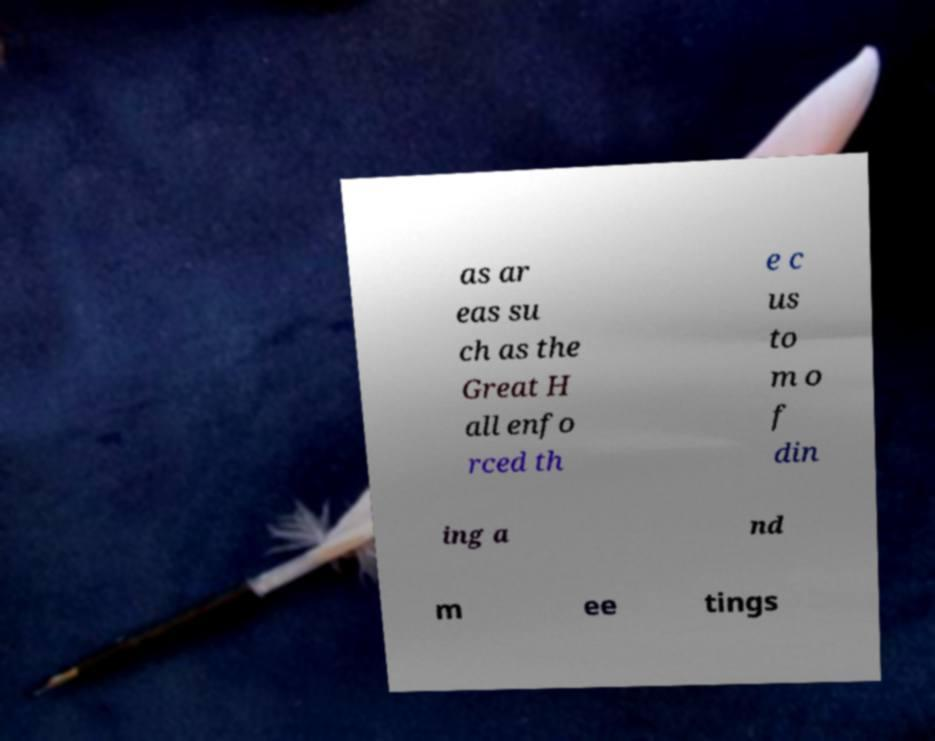I need the written content from this picture converted into text. Can you do that? as ar eas su ch as the Great H all enfo rced th e c us to m o f din ing a nd m ee tings 